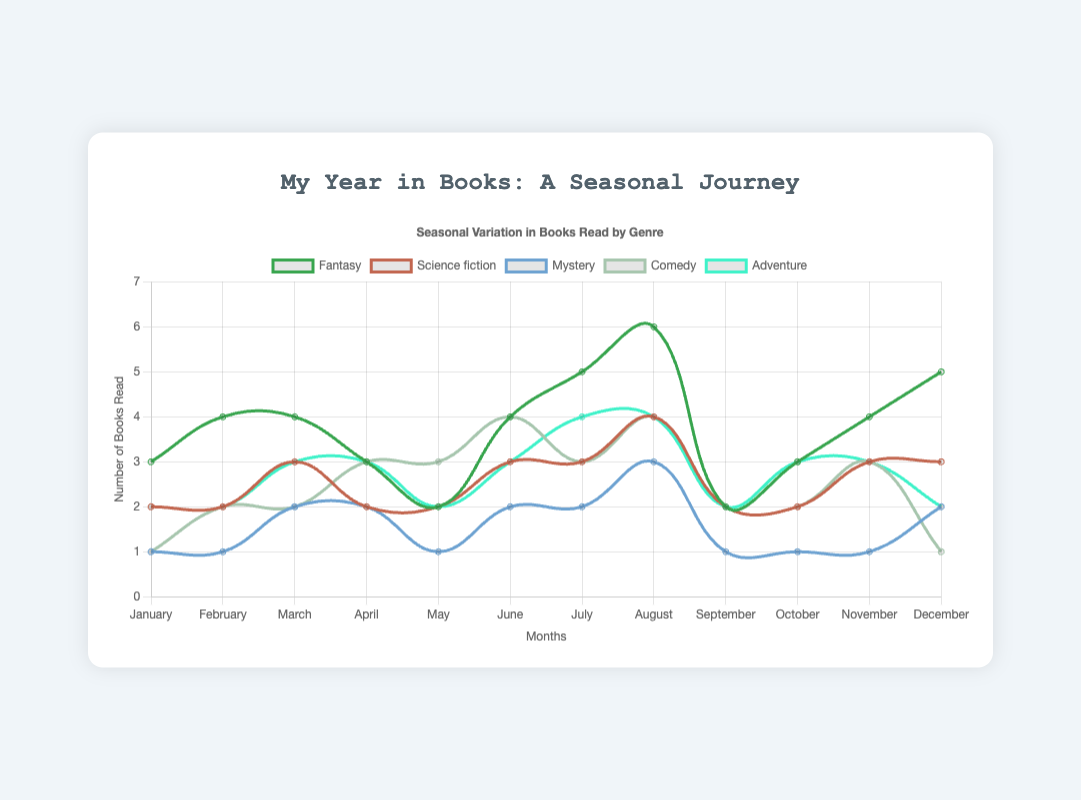What is the total number of fantasy books read in Winter? To find the total number of fantasy books read in Winter, sum the values for January, February, and December in the fantasy category: 3 (January) + 4 (February) + 5 (December) = 12.
Answer: 12 Which month had the highest number of comedy books read? To determine which month had the highest number of comedy books read, compare the comedy values for each month: January (1), February (2), March (2), April (3), May (3), June (4), July (3), August (4), September (2), October (2), November (3), December (1). The highest values are in June and August with 4 each.
Answer: June and August Did teenagers read more adventure books in Summer or Winter? Compare the total adventure books read in Summer (June: 3, July: 4, August: 4) and Winter (January: 2, February: 2, December: 2). Sum the values for each season: Summer = 3 + 4 + 4 = 11, Winter = 2 + 2 + 2 = 6.
Answer: Summer What is the average number of mystery books read per month in Spring? Calculate the average by adding the number of mystery books for March (2), April (2), and May (1), then dividing by the number of months: (2 + 2 + 1) / 3 = 5 / 3 ≈ 1.67.
Answer: 1.67 